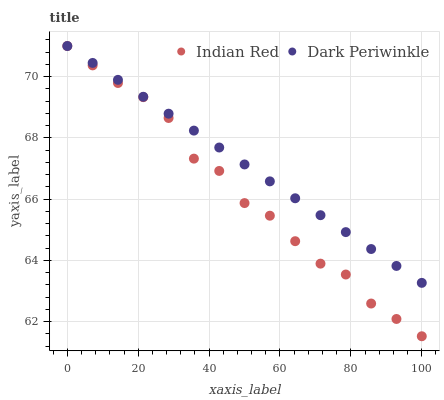Does Indian Red have the minimum area under the curve?
Answer yes or no. Yes. Does Dark Periwinkle have the maximum area under the curve?
Answer yes or no. Yes. Does Indian Red have the maximum area under the curve?
Answer yes or no. No. Is Dark Periwinkle the smoothest?
Answer yes or no. Yes. Is Indian Red the roughest?
Answer yes or no. Yes. Is Indian Red the smoothest?
Answer yes or no. No. Does Indian Red have the lowest value?
Answer yes or no. Yes. Does Indian Red have the highest value?
Answer yes or no. Yes. Does Indian Red intersect Dark Periwinkle?
Answer yes or no. Yes. Is Indian Red less than Dark Periwinkle?
Answer yes or no. No. Is Indian Red greater than Dark Periwinkle?
Answer yes or no. No. 